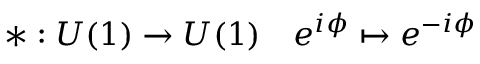Convert formula to latex. <formula><loc_0><loc_0><loc_500><loc_500>* \colon U ( 1 ) \to U ( 1 ) \quad e ^ { i \phi } \mapsto e ^ { - i \phi }</formula> 